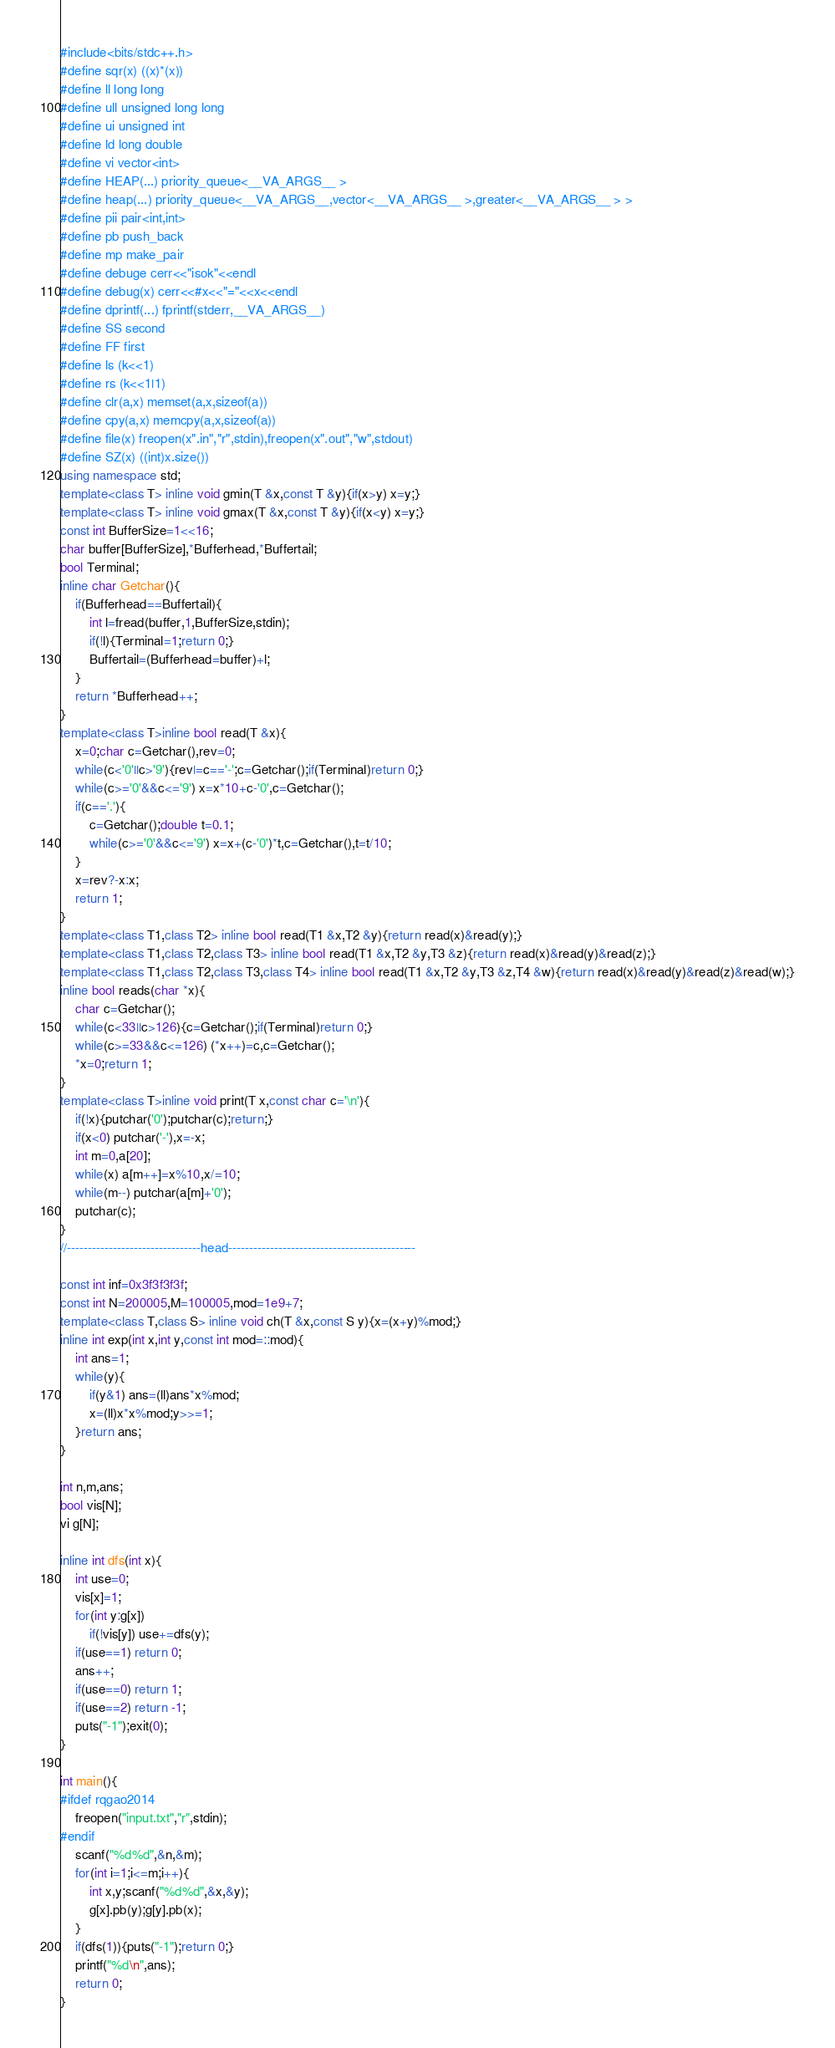<code> <loc_0><loc_0><loc_500><loc_500><_C++_>#include<bits/stdc++.h>
#define sqr(x) ((x)*(x))
#define ll long long
#define ull unsigned long long
#define ui unsigned int
#define ld long double
#define vi vector<int>
#define HEAP(...) priority_queue<__VA_ARGS__ >
#define heap(...) priority_queue<__VA_ARGS__,vector<__VA_ARGS__ >,greater<__VA_ARGS__ > > 
#define pii pair<int,int> 
#define pb push_back
#define mp make_pair
#define debuge cerr<<"isok"<<endl
#define debug(x) cerr<<#x<<"="<<x<<endl
#define dprintf(...) fprintf(stderr,__VA_ARGS__)
#define SS second
#define FF first
#define ls (k<<1)
#define rs (k<<1|1)
#define clr(a,x) memset(a,x,sizeof(a))
#define cpy(a,x) memcpy(a,x,sizeof(a))
#define file(x) freopen(x".in","r",stdin),freopen(x".out","w",stdout)
#define SZ(x) ((int)x.size())
using namespace std;
template<class T> inline void gmin(T &x,const T &y){if(x>y) x=y;}
template<class T> inline void gmax(T &x,const T &y){if(x<y) x=y;}
const int BufferSize=1<<16;
char buffer[BufferSize],*Bufferhead,*Buffertail;
bool Terminal;
inline char Getchar(){
	if(Bufferhead==Buffertail){
		int l=fread(buffer,1,BufferSize,stdin);
		if(!l){Terminal=1;return 0;}
		Buffertail=(Bufferhead=buffer)+l;
	}
	return *Bufferhead++;
}
template<class T>inline bool read(T &x){
	x=0;char c=Getchar(),rev=0;
	while(c<'0'||c>'9'){rev|=c=='-';c=Getchar();if(Terminal)return 0;}
	while(c>='0'&&c<='9') x=x*10+c-'0',c=Getchar();
	if(c=='.'){
		c=Getchar();double t=0.1;
		while(c>='0'&&c<='9') x=x+(c-'0')*t,c=Getchar(),t=t/10;
	}
	x=rev?-x:x;
	return 1;
}
template<class T1,class T2> inline bool read(T1 &x,T2 &y){return read(x)&read(y);}
template<class T1,class T2,class T3> inline bool read(T1 &x,T2 &y,T3 &z){return read(x)&read(y)&read(z);}
template<class T1,class T2,class T3,class T4> inline bool read(T1 &x,T2 &y,T3 &z,T4 &w){return read(x)&read(y)&read(z)&read(w);}
inline bool reads(char *x){
	char c=Getchar();
	while(c<33||c>126){c=Getchar();if(Terminal)return 0;}
	while(c>=33&&c<=126) (*x++)=c,c=Getchar();
	*x=0;return 1;
}
template<class T>inline void print(T x,const char c='\n'){
	if(!x){putchar('0');putchar(c);return;}
	if(x<0) putchar('-'),x=-x;
	int m=0,a[20];
	while(x) a[m++]=x%10,x/=10;
	while(m--) putchar(a[m]+'0');
	putchar(c);
}
//--------------------------------head---------------------------------------------

const int inf=0x3f3f3f3f;
const int N=200005,M=100005,mod=1e9+7;
template<class T,class S> inline void ch(T &x,const S y){x=(x+y)%mod;}
inline int exp(int x,int y,const int mod=::mod){
	int ans=1;
	while(y){
		if(y&1) ans=(ll)ans*x%mod;
		x=(ll)x*x%mod;y>>=1;
	}return ans;
}

int n,m,ans;
bool vis[N];
vi g[N];

inline int dfs(int x){
	int use=0;
	vis[x]=1;
	for(int y:g[x])
		if(!vis[y]) use+=dfs(y);
	if(use==1) return 0;
	ans++;
	if(use==0) return 1;
	if(use==2) return -1;
	puts("-1");exit(0);
}

int main(){
#ifdef rqgao2014
	freopen("input.txt","r",stdin);
#endif
	scanf("%d%d",&n,&m);
	for(int i=1;i<=m;i++){
		int x,y;scanf("%d%d",&x,&y);
		g[x].pb(y);g[y].pb(x);
	}
	if(dfs(1)){puts("-1");return 0;}
	printf("%d\n",ans);
	return 0;
}</code> 